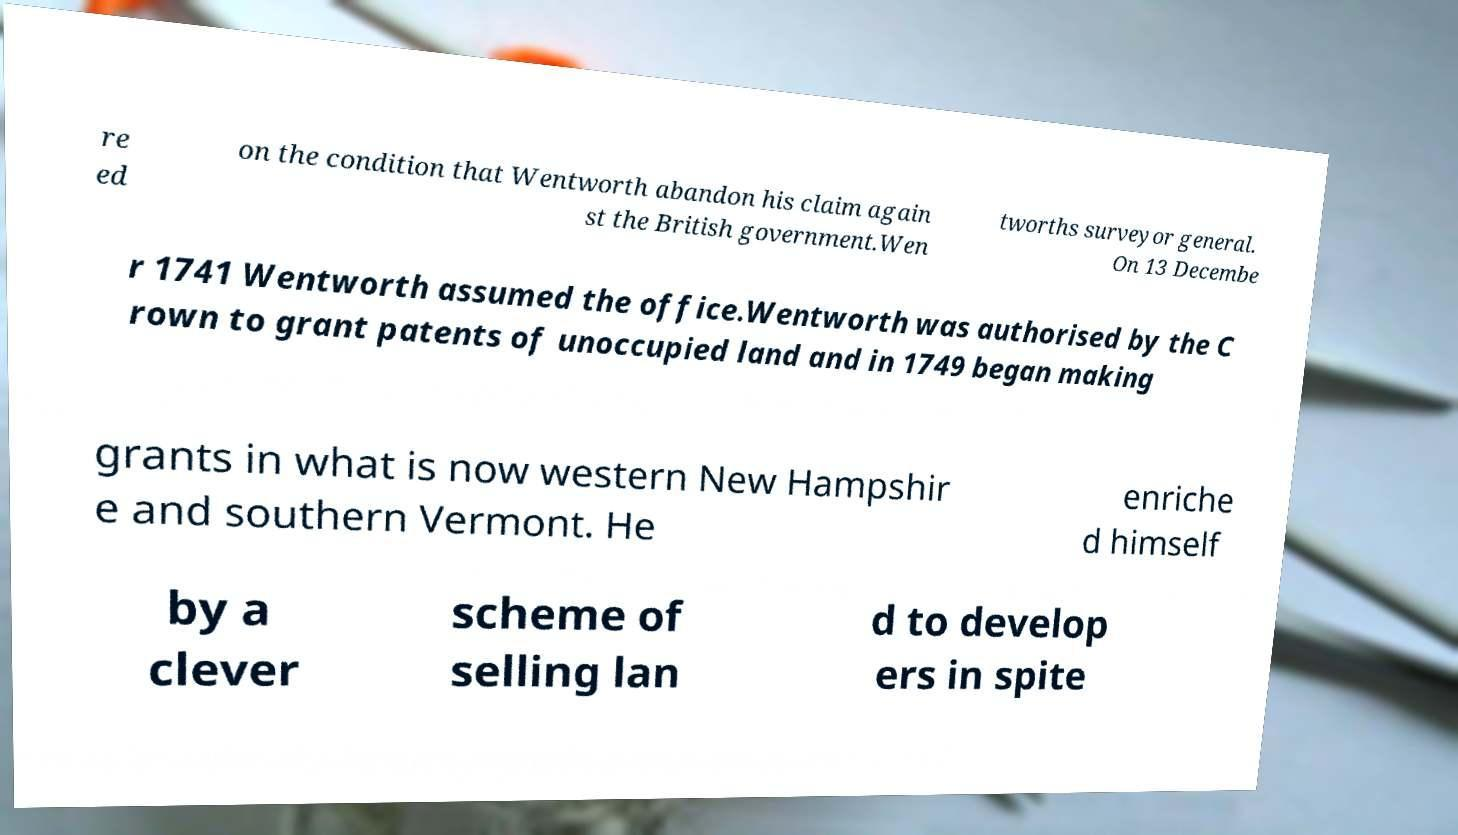Can you accurately transcribe the text from the provided image for me? re ed on the condition that Wentworth abandon his claim again st the British government.Wen tworths surveyor general. On 13 Decembe r 1741 Wentworth assumed the office.Wentworth was authorised by the C rown to grant patents of unoccupied land and in 1749 began making grants in what is now western New Hampshir e and southern Vermont. He enriche d himself by a clever scheme of selling lan d to develop ers in spite 